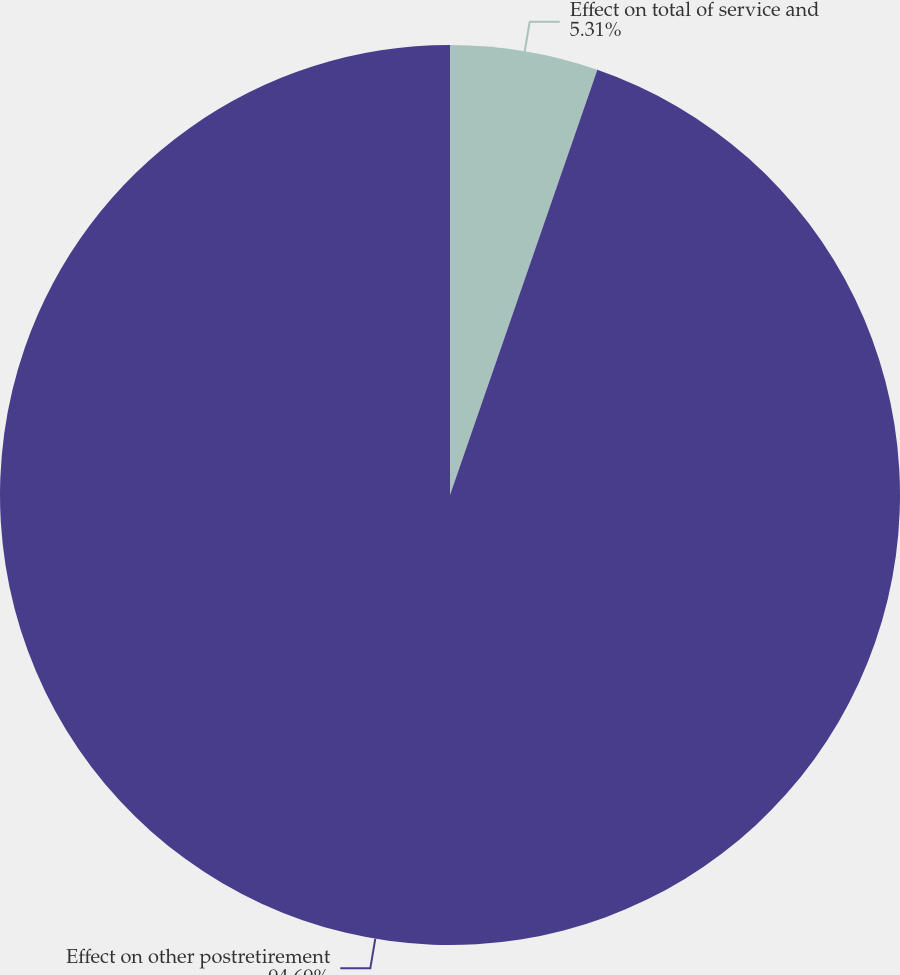<chart> <loc_0><loc_0><loc_500><loc_500><pie_chart><fcel>Effect on total of service and<fcel>Effect on other postretirement<nl><fcel>5.31%<fcel>94.69%<nl></chart> 